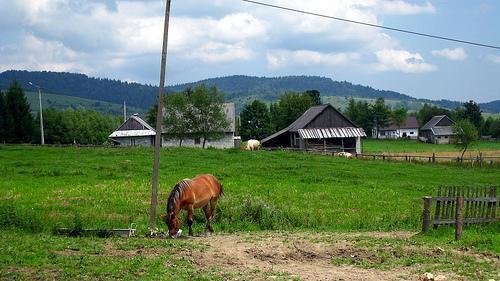How many horses are there?
Give a very brief answer. 1. 